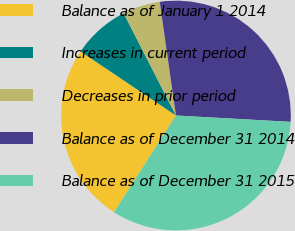Convert chart to OTSL. <chart><loc_0><loc_0><loc_500><loc_500><pie_chart><fcel>Balance as of January 1 2014<fcel>Increases in current period<fcel>Decreases in prior period<fcel>Balance as of December 31 2014<fcel>Balance as of December 31 2015<nl><fcel>25.35%<fcel>8.06%<fcel>5.27%<fcel>28.14%<fcel>33.18%<nl></chart> 